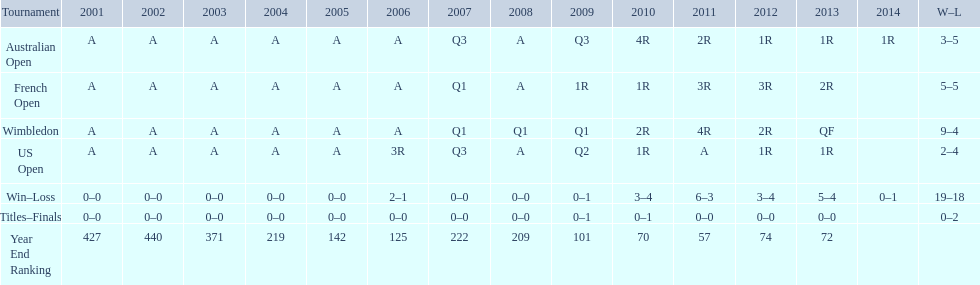Can you parse all the data within this table? {'header': ['Tournament', '2001', '2002', '2003', '2004', '2005', '2006', '2007', '2008', '2009', '2010', '2011', '2012', '2013', '2014', 'W–L'], 'rows': [['Australian Open', 'A', 'A', 'A', 'A', 'A', 'A', 'Q3', 'A', 'Q3', '4R', '2R', '1R', '1R', '1R', '3–5'], ['French Open', 'A', 'A', 'A', 'A', 'A', 'A', 'Q1', 'A', '1R', '1R', '3R', '3R', '2R', '', '5–5'], ['Wimbledon', 'A', 'A', 'A', 'A', 'A', 'A', 'Q1', 'Q1', 'Q1', '2R', '4R', '2R', 'QF', '', '9–4'], ['US Open', 'A', 'A', 'A', 'A', 'A', '3R', 'Q3', 'A', 'Q2', '1R', 'A', '1R', '1R', '', '2–4'], ['Win–Loss', '0–0', '0–0', '0–0', '0–0', '0–0', '2–1', '0–0', '0–0', '0–1', '3–4', '6–3', '3–4', '5–4', '0–1', '19–18'], ['Titles–Finals', '0–0', '0–0', '0–0', '0–0', '0–0', '0–0', '0–0', '0–0', '0–1', '0–1', '0–0', '0–0', '0–0', '', '0–2'], ['Year End Ranking', '427', '440', '371', '219', '142', '125', '222', '209', '101', '70', '57', '74', '72', '', '']]} In which year was the highest year-end ranking attained? 2011. 